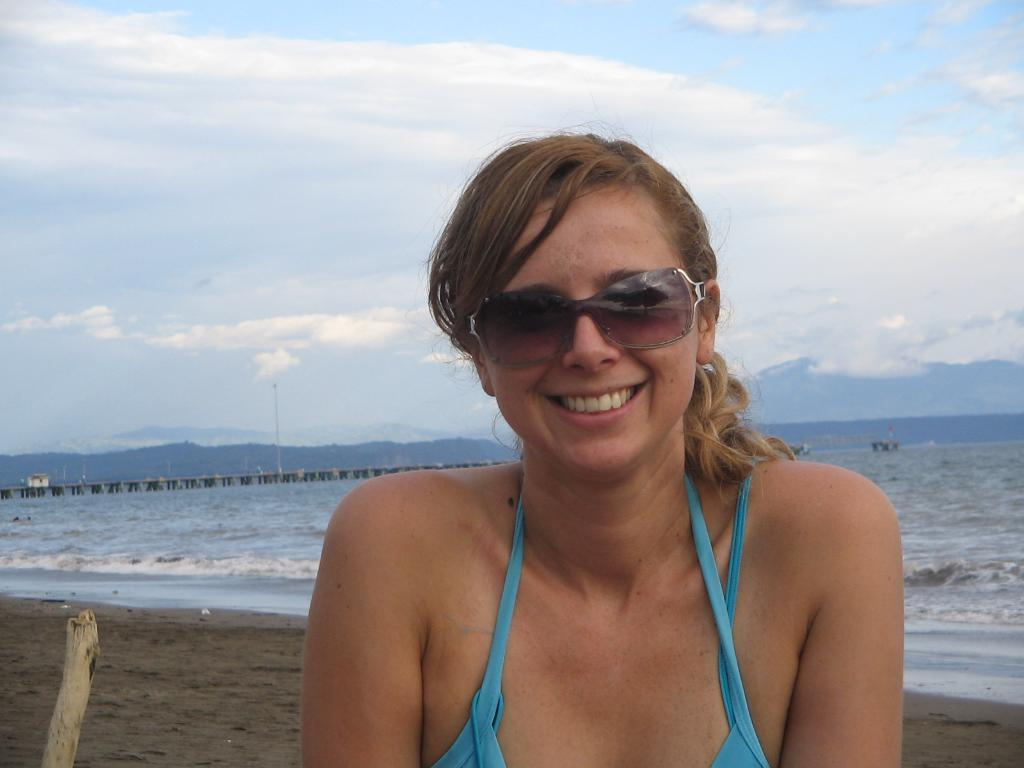Who is the main subject in the image? There is a girl in the center of the image. What can be seen in the background of the image? There is water in the background of the image. What type of plant is visible at the bottom side of the image? There is a bamboo at the bottom side of the image. Can you see any birds dancing in the ocean in the image? There is no ocean or birds visible in the image; it features a red car with four wheels on a paved road. 